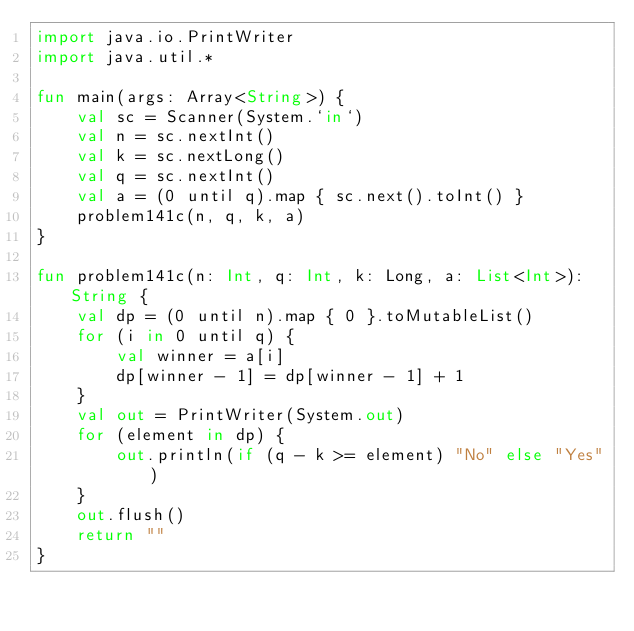Convert code to text. <code><loc_0><loc_0><loc_500><loc_500><_Kotlin_>import java.io.PrintWriter
import java.util.*

fun main(args: Array<String>) {
    val sc = Scanner(System.`in`)
    val n = sc.nextInt()
    val k = sc.nextLong()
    val q = sc.nextInt()
    val a = (0 until q).map { sc.next().toInt() }
    problem141c(n, q, k, a)
}

fun problem141c(n: Int, q: Int, k: Long, a: List<Int>): String {
    val dp = (0 until n).map { 0 }.toMutableList()
    for (i in 0 until q) {
        val winner = a[i]
        dp[winner - 1] = dp[winner - 1] + 1
    }
    val out = PrintWriter(System.out)
    for (element in dp) {
        out.println(if (q - k >= element) "No" else "Yes")
    }
    out.flush()
    return ""
}</code> 